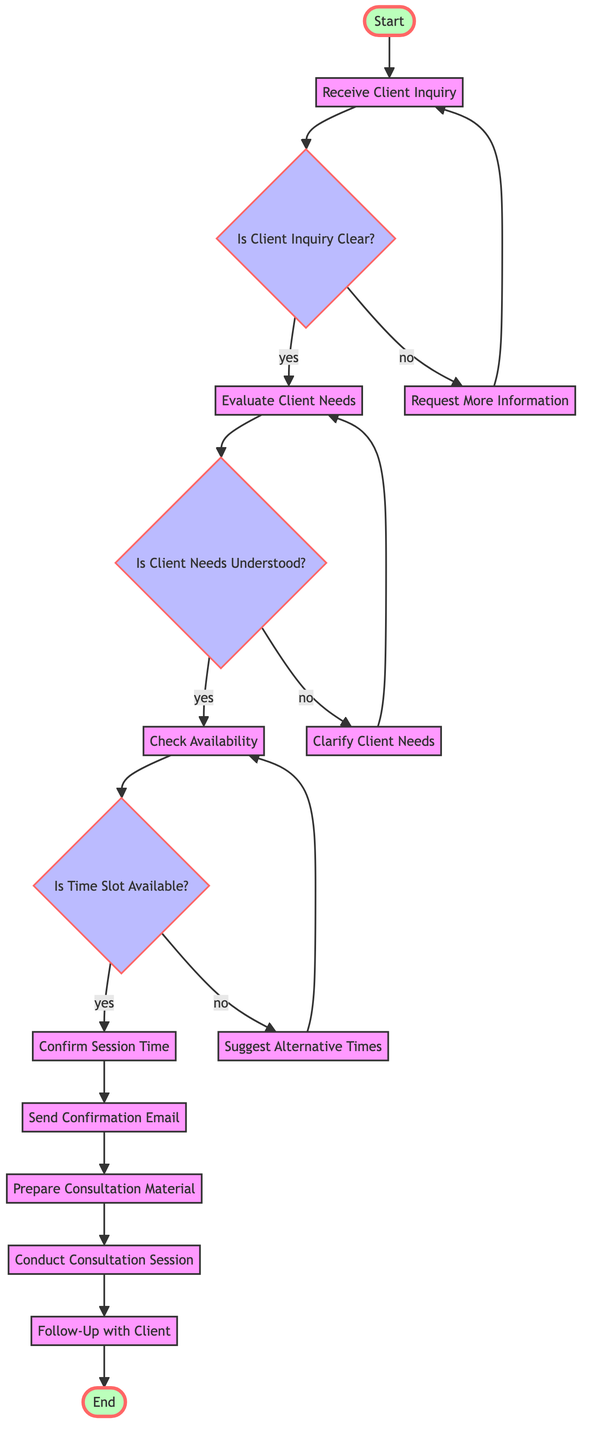What is the first activity in the diagram? The diagram starts with the "Start" node, which flows into "Receive Client Inquiry." Therefore, the first activity is directly related to receiving inquiries from clients.
Answer: Receive Client Inquiry How many decision nodes are in the diagram? There are three decision nodes identified: "Is Client Inquiry Clear?", "Is Client Needs Understood?", and "Is Time Slot Available?". Counting these, we find there are three decision nodes in total.
Answer: 3 What happens if the client inquiry is not clear? If the client inquiry is not clear, the flow goes to "Request More Information," after which it loops back to "Receive Client Inquiry." This indicates that clarity is needed before proceeding.
Answer: Request More Information What is the final activity before reaching the end of the process? The final activity before the end of the process is "Follow-Up with Client." This is the last action taken after conducting the consultation session.
Answer: Follow-Up with Client What action occurs after confirming the session time? After confirming the session time, the next action is "Send Confirmation Email," which indicates that communication is sent out to the client regarding the scheduled session.
Answer: Send Confirmation Email What condition leads to evaluating client needs? The condition that leads to evaluating client needs is when the inquiry is confirmed to be clear, as shown by the flow from "Is Client Inquiry Clear?" to "Evaluate Client Needs" under the "yes" condition.
Answer: yes What should be done if the client's needs are not understood? If the client's needs are not understood, the flow moves to "Clarify Client Needs," indicating a need for further discussion to ensure understanding before proceeding to check availability.
Answer: Clarify Client Needs 